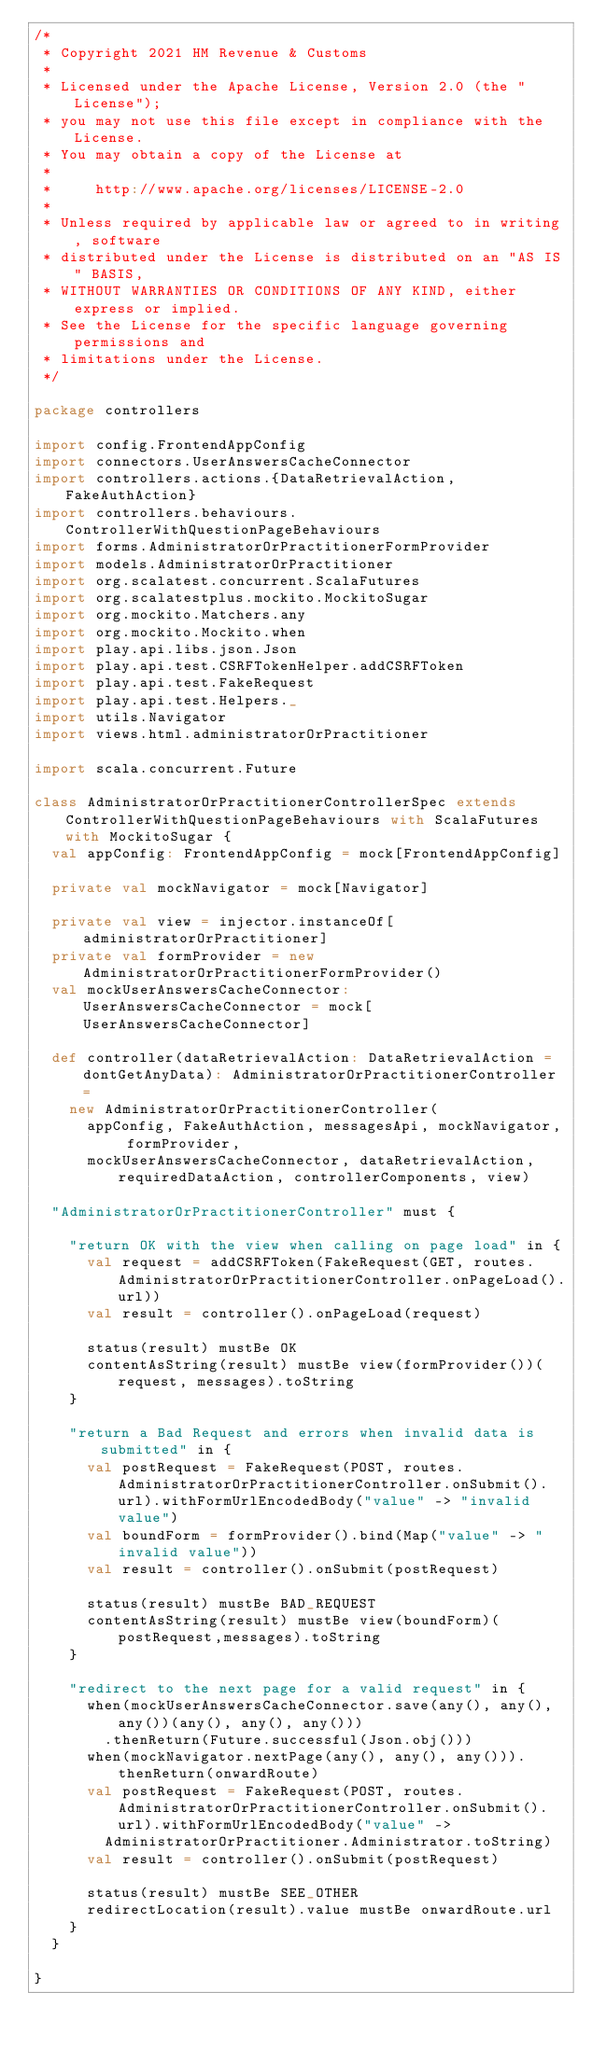<code> <loc_0><loc_0><loc_500><loc_500><_Scala_>/*
 * Copyright 2021 HM Revenue & Customs
 *
 * Licensed under the Apache License, Version 2.0 (the "License");
 * you may not use this file except in compliance with the License.
 * You may obtain a copy of the License at
 *
 *     http://www.apache.org/licenses/LICENSE-2.0
 *
 * Unless required by applicable law or agreed to in writing, software
 * distributed under the License is distributed on an "AS IS" BASIS,
 * WITHOUT WARRANTIES OR CONDITIONS OF ANY KIND, either express or implied.
 * See the License for the specific language governing permissions and
 * limitations under the License.
 */

package controllers

import config.FrontendAppConfig
import connectors.UserAnswersCacheConnector
import controllers.actions.{DataRetrievalAction, FakeAuthAction}
import controllers.behaviours.ControllerWithQuestionPageBehaviours
import forms.AdministratorOrPractitionerFormProvider
import models.AdministratorOrPractitioner
import org.scalatest.concurrent.ScalaFutures
import org.scalatestplus.mockito.MockitoSugar
import org.mockito.Matchers.any
import org.mockito.Mockito.when
import play.api.libs.json.Json
import play.api.test.CSRFTokenHelper.addCSRFToken
import play.api.test.FakeRequest
import play.api.test.Helpers._
import utils.Navigator
import views.html.administratorOrPractitioner

import scala.concurrent.Future

class AdministratorOrPractitionerControllerSpec extends ControllerWithQuestionPageBehaviours with ScalaFutures with MockitoSugar {
  val appConfig: FrontendAppConfig = mock[FrontendAppConfig]

  private val mockNavigator = mock[Navigator]

  private val view = injector.instanceOf[administratorOrPractitioner]
  private val formProvider = new AdministratorOrPractitionerFormProvider()
  val mockUserAnswersCacheConnector: UserAnswersCacheConnector = mock[UserAnswersCacheConnector]

  def controller(dataRetrievalAction: DataRetrievalAction = dontGetAnyData): AdministratorOrPractitionerController =
    new AdministratorOrPractitionerController(
      appConfig, FakeAuthAction, messagesApi, mockNavigator, formProvider,
      mockUserAnswersCacheConnector, dataRetrievalAction, requiredDataAction, controllerComponents, view)

  "AdministratorOrPractitionerController" must {

    "return OK with the view when calling on page load" in {
      val request = addCSRFToken(FakeRequest(GET, routes.AdministratorOrPractitionerController.onPageLoad().url))
      val result = controller().onPageLoad(request)

      status(result) mustBe OK
      contentAsString(result) mustBe view(formProvider())(request, messages).toString
    }

    "return a Bad Request and errors when invalid data is submitted" in {
      val postRequest = FakeRequest(POST, routes.AdministratorOrPractitionerController.onSubmit().url).withFormUrlEncodedBody("value" -> "invalid value")
      val boundForm = formProvider().bind(Map("value" -> "invalid value"))
      val result = controller().onSubmit(postRequest)

      status(result) mustBe BAD_REQUEST
      contentAsString(result) mustBe view(boundForm)(postRequest,messages).toString
    }

    "redirect to the next page for a valid request" in {
      when(mockUserAnswersCacheConnector.save(any(), any(), any())(any(), any(), any()))
        .thenReturn(Future.successful(Json.obj()))
      when(mockNavigator.nextPage(any(), any(), any())).thenReturn(onwardRoute)
      val postRequest = FakeRequest(POST, routes.AdministratorOrPractitionerController.onSubmit().url).withFormUrlEncodedBody("value" ->
        AdministratorOrPractitioner.Administrator.toString)
      val result = controller().onSubmit(postRequest)

      status(result) mustBe SEE_OTHER
      redirectLocation(result).value mustBe onwardRoute.url
    }
  }

}




</code> 